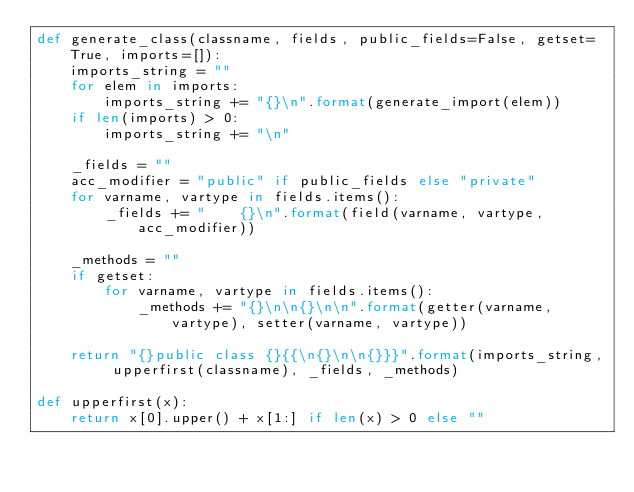<code> <loc_0><loc_0><loc_500><loc_500><_Python_>def generate_class(classname, fields, public_fields=False, getset=True, imports=[]):
    imports_string = ""
    for elem in imports:
        imports_string += "{}\n".format(generate_import(elem))
    if len(imports) > 0:
        imports_string += "\n"

    _fields = ""
    acc_modifier = "public" if public_fields else "private"
    for varname, vartype in fields.items():
        _fields += "    {}\n".format(field(varname, vartype, acc_modifier))

    _methods = ""
    if getset:
        for varname, vartype in fields.items():
            _methods += "{}\n\n{}\n\n".format(getter(varname, vartype), setter(varname, vartype))

    return "{}public class {}{{\n{}\n\n{}}}".format(imports_string, upperfirst(classname), _fields, _methods)

def upperfirst(x):
    return x[0].upper() + x[1:] if len(x) > 0 else ""</code> 